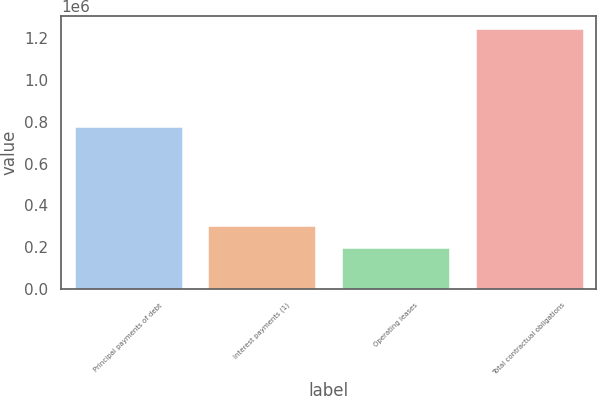Convert chart. <chart><loc_0><loc_0><loc_500><loc_500><bar_chart><fcel>Principal payments of debt<fcel>Interest payments (1)<fcel>Operating leases<fcel>Total contractual obligations<nl><fcel>775000<fcel>299040<fcel>194228<fcel>1.24234e+06<nl></chart> 